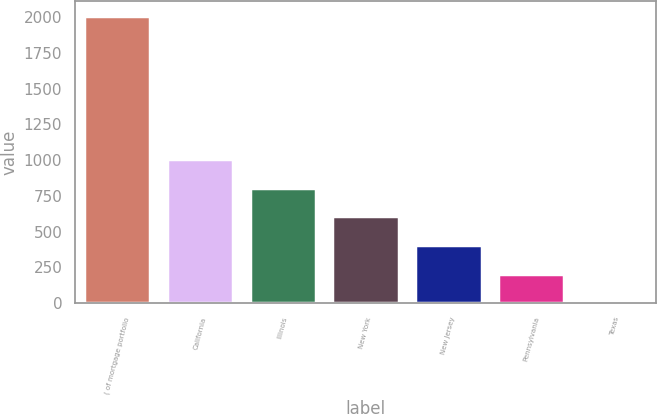<chart> <loc_0><loc_0><loc_500><loc_500><bar_chart><fcel>( of mortgage portfolio<fcel>California<fcel>Illinois<fcel>New York<fcel>New Jersey<fcel>Pennsylvania<fcel>Texas<nl><fcel>2010<fcel>1007.65<fcel>807.18<fcel>606.71<fcel>406.24<fcel>205.77<fcel>5.3<nl></chart> 